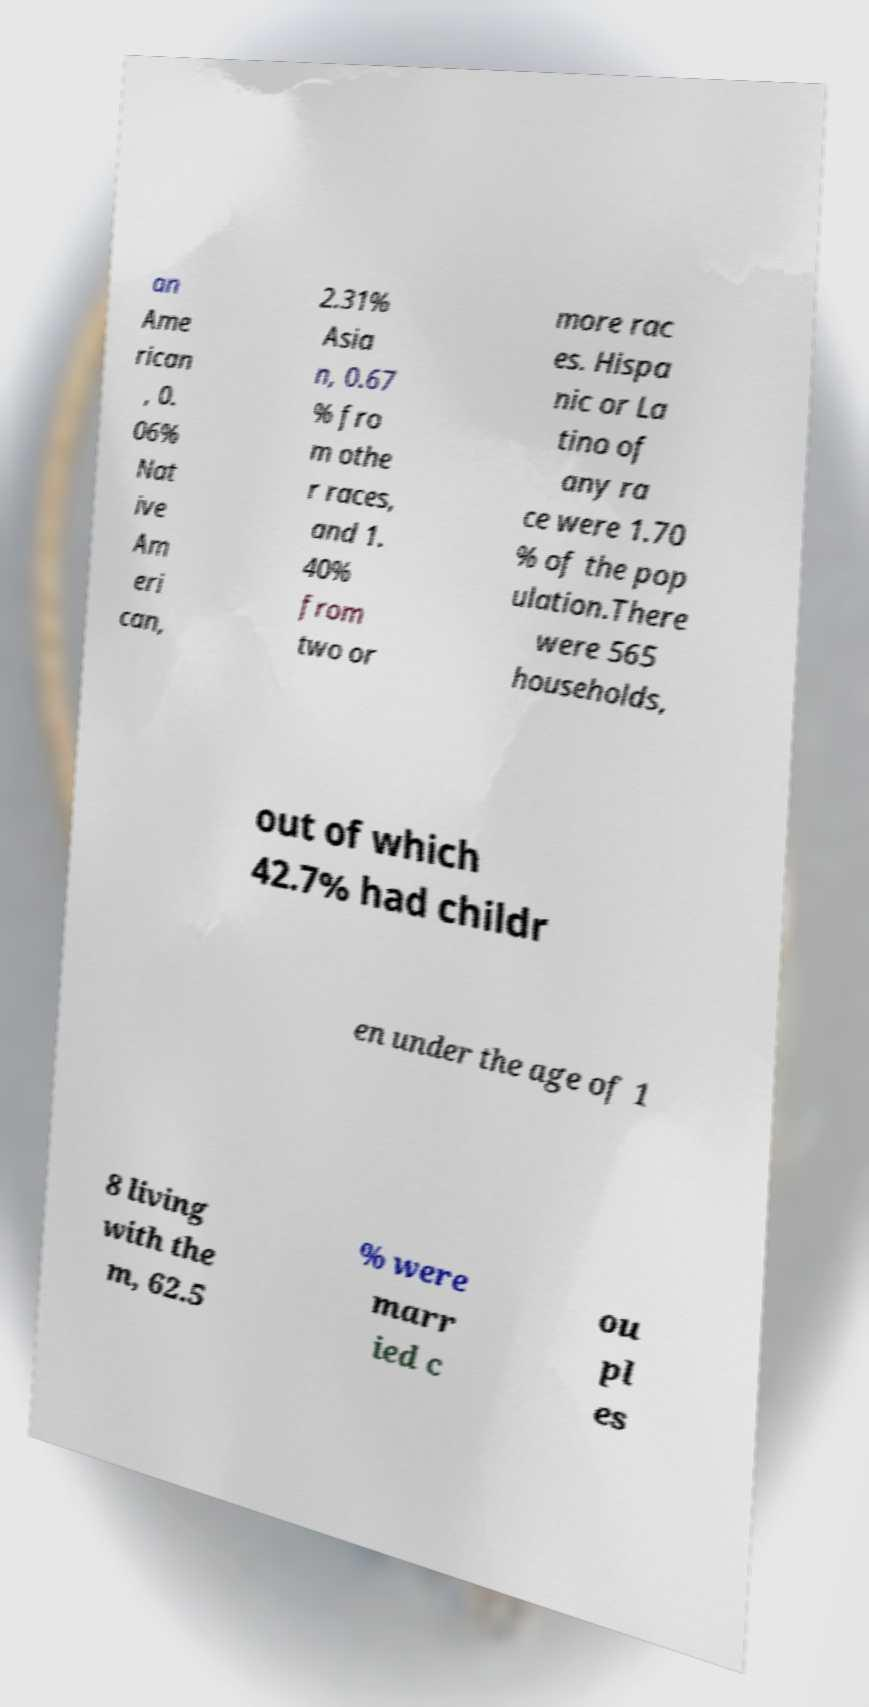For documentation purposes, I need the text within this image transcribed. Could you provide that? an Ame rican , 0. 06% Nat ive Am eri can, 2.31% Asia n, 0.67 % fro m othe r races, and 1. 40% from two or more rac es. Hispa nic or La tino of any ra ce were 1.70 % of the pop ulation.There were 565 households, out of which 42.7% had childr en under the age of 1 8 living with the m, 62.5 % were marr ied c ou pl es 